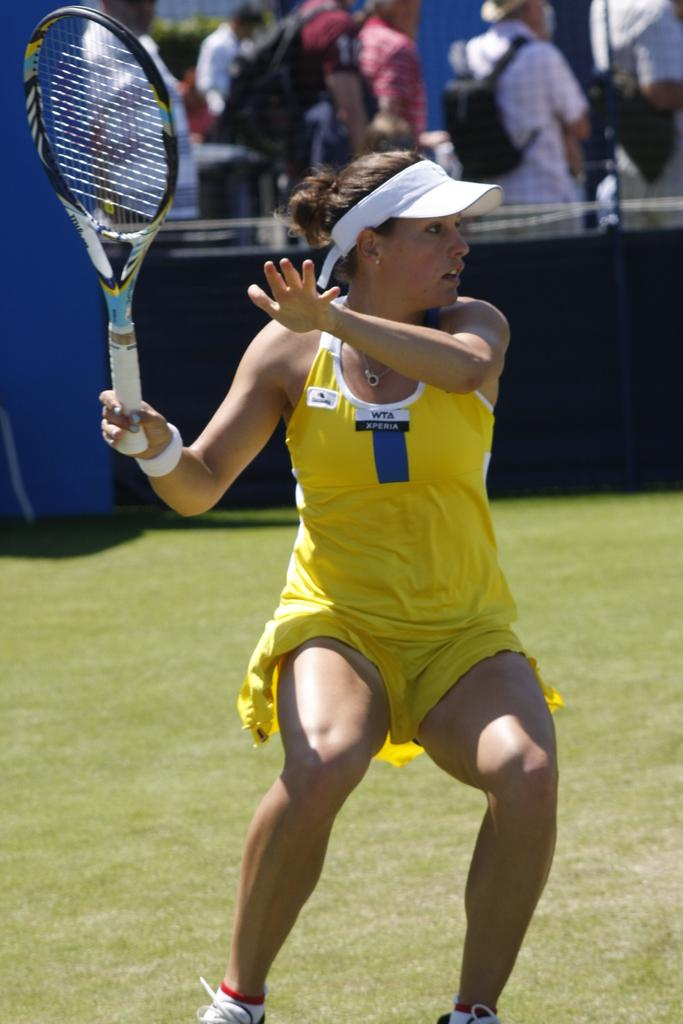Who is the main subject in the image? There is a woman in the image. What is the woman doing in the image? The woman is standing on the ground and holding a racket in her hands. Can you describe the background of the image? There is a group of people in the background of the image. What type of nut is the woman trying to crack with the racket in the image? There is no nut present in the image, and the woman is not using the racket to crack a nut. 